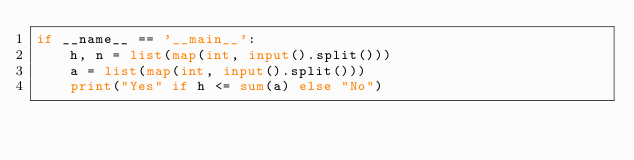Convert code to text. <code><loc_0><loc_0><loc_500><loc_500><_Python_>if __name__ == '__main__':
    h, n = list(map(int, input().split()))
    a = list(map(int, input().split()))
    print("Yes" if h <= sum(a) else "No")</code> 